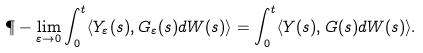Convert formula to latex. <formula><loc_0><loc_0><loc_500><loc_500>\P - \lim _ { \varepsilon \to 0 } \int _ { 0 } ^ { t } \langle Y _ { \varepsilon } ( s ) , G _ { \varepsilon } ( s ) d W ( s ) \rangle = \int _ { 0 } ^ { t } \langle Y ( s ) , G ( s ) d W ( s ) \rangle .</formula> 